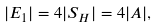Convert formula to latex. <formula><loc_0><loc_0><loc_500><loc_500>| E _ { 1 } | = 4 | S _ { H } | = 4 | A | ,</formula> 